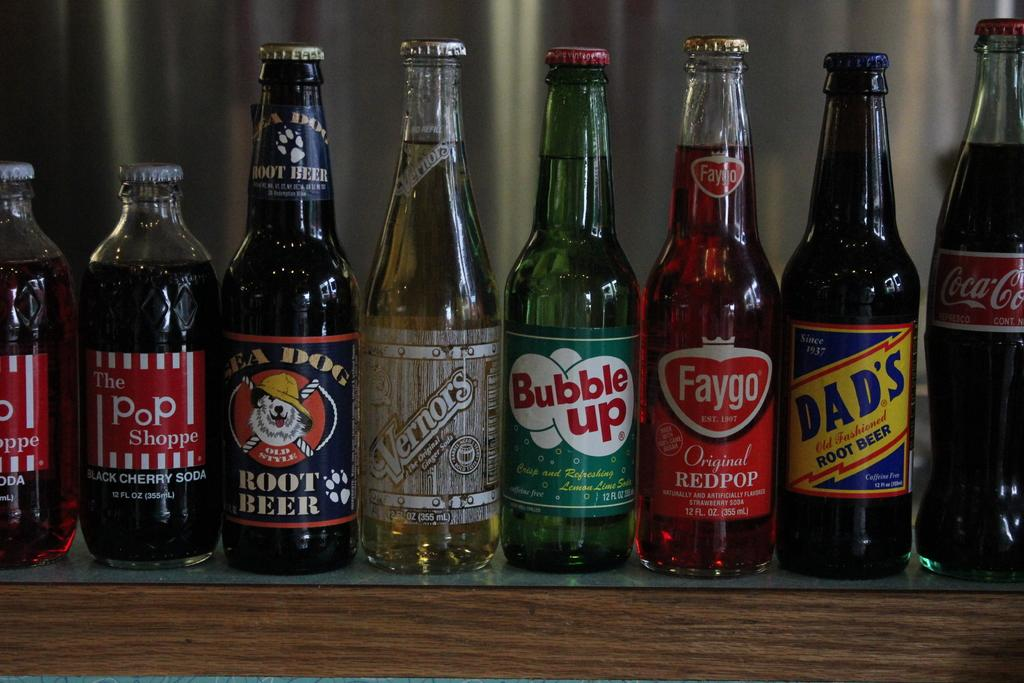<image>
Describe the image concisely. A bottle of Bubble Up, Faygo, Dad's, Coca Cola, Vernors, Root Beer, and Pop. 